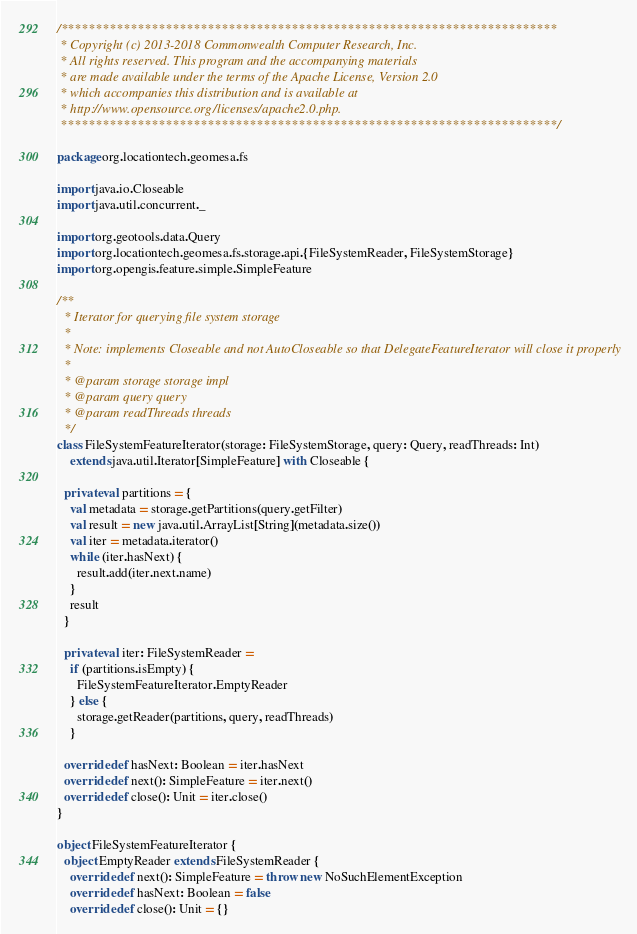Convert code to text. <code><loc_0><loc_0><loc_500><loc_500><_Scala_>/***********************************************************************
 * Copyright (c) 2013-2018 Commonwealth Computer Research, Inc.
 * All rights reserved. This program and the accompanying materials
 * are made available under the terms of the Apache License, Version 2.0
 * which accompanies this distribution and is available at
 * http://www.opensource.org/licenses/apache2.0.php.
 ***********************************************************************/

package org.locationtech.geomesa.fs

import java.io.Closeable
import java.util.concurrent._

import org.geotools.data.Query
import org.locationtech.geomesa.fs.storage.api.{FileSystemReader, FileSystemStorage}
import org.opengis.feature.simple.SimpleFeature

/**
  * Iterator for querying file system storage
  *
  * Note: implements Closeable and not AutoCloseable so that DelegateFeatureIterator will close it properly
  *
  * @param storage storage impl
  * @param query query
  * @param readThreads threads
  */
class FileSystemFeatureIterator(storage: FileSystemStorage, query: Query, readThreads: Int)
    extends java.util.Iterator[SimpleFeature] with Closeable {

  private val partitions = {
    val metadata = storage.getPartitions(query.getFilter)
    val result = new java.util.ArrayList[String](metadata.size())
    val iter = metadata.iterator()
    while (iter.hasNext) {
      result.add(iter.next.name)
    }
    result
  }

  private val iter: FileSystemReader =
    if (partitions.isEmpty) {
      FileSystemFeatureIterator.EmptyReader
    } else {
      storage.getReader(partitions, query, readThreads)
    }

  override def hasNext: Boolean = iter.hasNext
  override def next(): SimpleFeature = iter.next()
  override def close(): Unit = iter.close()
}

object FileSystemFeatureIterator {
  object EmptyReader extends FileSystemReader {
    override def next(): SimpleFeature = throw new NoSuchElementException
    override def hasNext: Boolean = false
    override def close(): Unit = {}</code> 